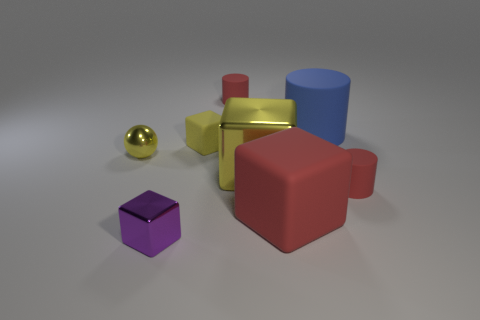Are there any other things that are the same color as the small metallic sphere?
Provide a succinct answer. Yes. There is a ball; does it have the same color as the metallic object that is right of the tiny purple object?
Your response must be concise. Yes. How many objects are large red things or tiny matte cylinders?
Offer a terse response. 3. There is a ball that is the same color as the large metallic object; what is its size?
Your answer should be very brief. Small. Are there any tiny red matte cylinders on the left side of the big yellow shiny object?
Offer a very short reply. Yes. Are there more small red matte cylinders that are behind the tiny yellow rubber cube than large blue matte things in front of the purple thing?
Give a very brief answer. Yes. What is the size of the yellow shiny thing that is the same shape as the large red thing?
Make the answer very short. Large. What number of blocks are either purple shiny objects or big yellow objects?
Provide a succinct answer. 2. What material is the large object that is the same color as the small metal ball?
Offer a very short reply. Metal. Is the number of yellow shiny balls behind the sphere less than the number of large yellow cubes that are behind the tiny shiny cube?
Keep it short and to the point. Yes. 